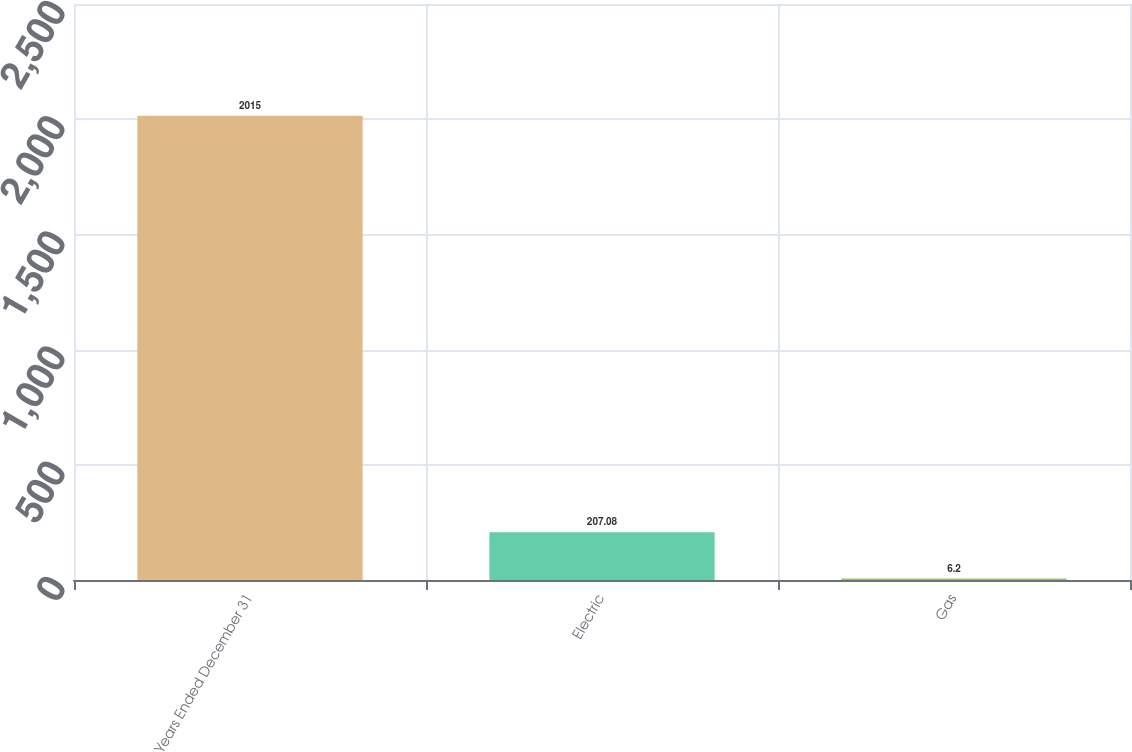Convert chart to OTSL. <chart><loc_0><loc_0><loc_500><loc_500><bar_chart><fcel>Years Ended December 31<fcel>Electric<fcel>Gas<nl><fcel>2015<fcel>207.08<fcel>6.2<nl></chart> 